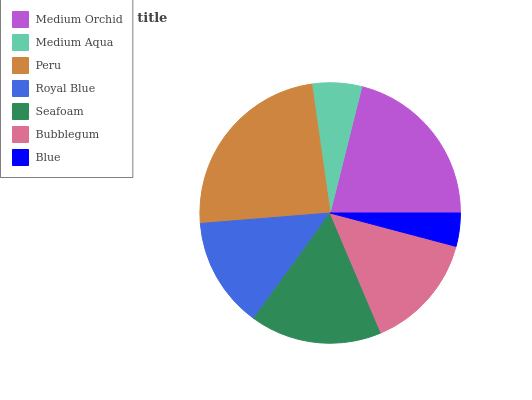Is Blue the minimum?
Answer yes or no. Yes. Is Peru the maximum?
Answer yes or no. Yes. Is Medium Aqua the minimum?
Answer yes or no. No. Is Medium Aqua the maximum?
Answer yes or no. No. Is Medium Orchid greater than Medium Aqua?
Answer yes or no. Yes. Is Medium Aqua less than Medium Orchid?
Answer yes or no. Yes. Is Medium Aqua greater than Medium Orchid?
Answer yes or no. No. Is Medium Orchid less than Medium Aqua?
Answer yes or no. No. Is Bubblegum the high median?
Answer yes or no. Yes. Is Bubblegum the low median?
Answer yes or no. Yes. Is Peru the high median?
Answer yes or no. No. Is Blue the low median?
Answer yes or no. No. 